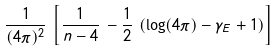Convert formula to latex. <formula><loc_0><loc_0><loc_500><loc_500>\frac { 1 } { ( 4 \pi ) ^ { 2 } } \, \left [ \frac { 1 } { n - 4 } \, - \frac { 1 } { 2 } \, \left ( \log ( 4 \pi ) - \gamma _ { E } + 1 \right ) \right ]</formula> 